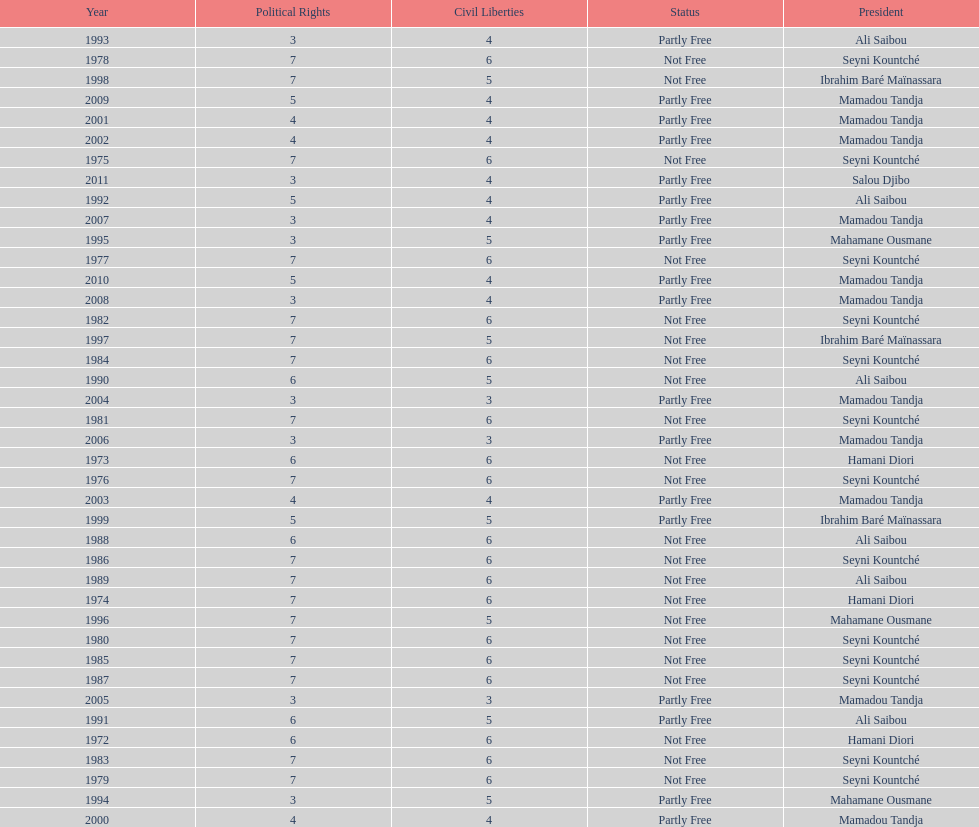What is the number of time seyni kountche has been president? 13. 